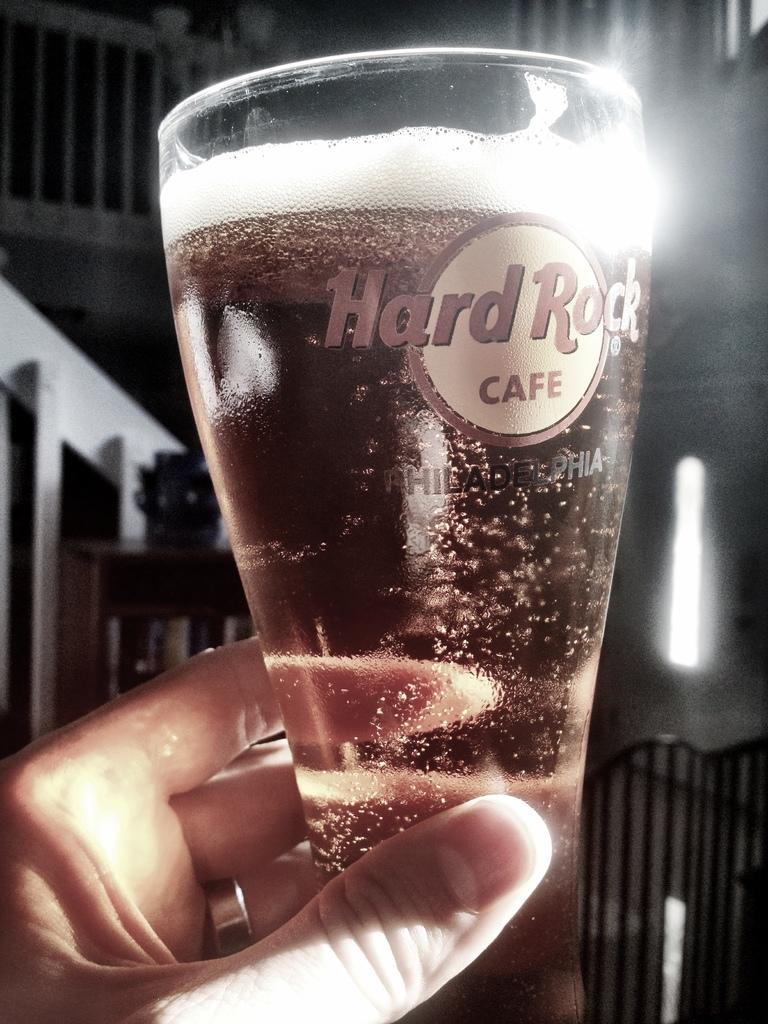<image>
Describe the image concisely. A close up image of a carbonated beverage in a Hard Rock Cafe glass. 